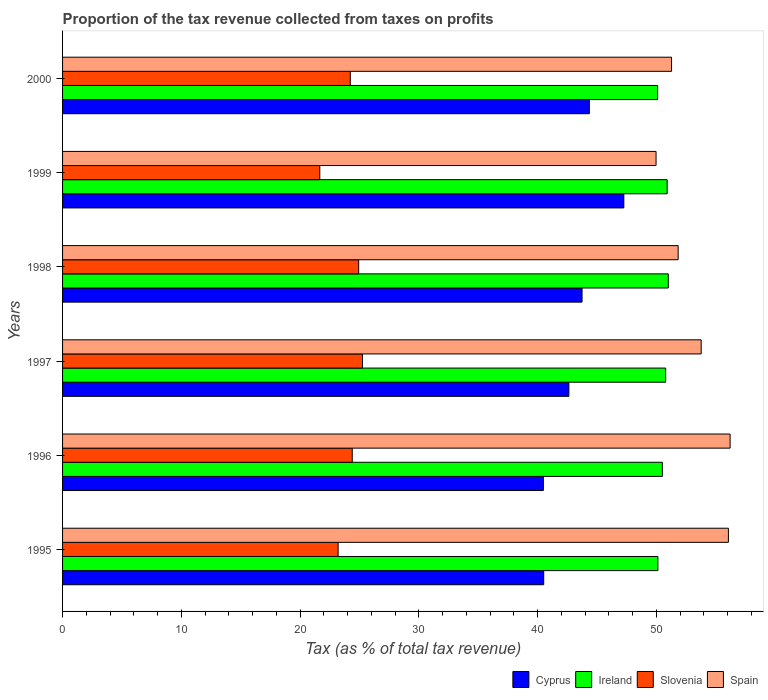How many different coloured bars are there?
Keep it short and to the point. 4. How many groups of bars are there?
Make the answer very short. 6. How many bars are there on the 6th tick from the bottom?
Provide a succinct answer. 4. What is the label of the 5th group of bars from the top?
Your response must be concise. 1996. In how many cases, is the number of bars for a given year not equal to the number of legend labels?
Offer a terse response. 0. What is the proportion of the tax revenue collected in Spain in 2000?
Your answer should be very brief. 51.28. Across all years, what is the maximum proportion of the tax revenue collected in Ireland?
Your response must be concise. 51. Across all years, what is the minimum proportion of the tax revenue collected in Slovenia?
Offer a terse response. 21.66. In which year was the proportion of the tax revenue collected in Ireland minimum?
Offer a very short reply. 2000. What is the total proportion of the tax revenue collected in Ireland in the graph?
Your answer should be compact. 303.43. What is the difference between the proportion of the tax revenue collected in Cyprus in 1995 and that in 2000?
Your answer should be compact. -3.84. What is the difference between the proportion of the tax revenue collected in Spain in 1995 and the proportion of the tax revenue collected in Ireland in 1998?
Keep it short and to the point. 5.06. What is the average proportion of the tax revenue collected in Slovenia per year?
Provide a succinct answer. 23.94. In the year 1999, what is the difference between the proportion of the tax revenue collected in Slovenia and proportion of the tax revenue collected in Ireland?
Your answer should be very brief. -29.25. What is the ratio of the proportion of the tax revenue collected in Spain in 1995 to that in 1999?
Offer a very short reply. 1.12. Is the difference between the proportion of the tax revenue collected in Slovenia in 1996 and 2000 greater than the difference between the proportion of the tax revenue collected in Ireland in 1996 and 2000?
Give a very brief answer. No. What is the difference between the highest and the second highest proportion of the tax revenue collected in Slovenia?
Offer a terse response. 0.32. What is the difference between the highest and the lowest proportion of the tax revenue collected in Cyprus?
Your answer should be very brief. 6.78. What does the 1st bar from the top in 2000 represents?
Give a very brief answer. Spain. What does the 2nd bar from the bottom in 1995 represents?
Offer a very short reply. Ireland. Is it the case that in every year, the sum of the proportion of the tax revenue collected in Slovenia and proportion of the tax revenue collected in Ireland is greater than the proportion of the tax revenue collected in Spain?
Your response must be concise. Yes. How many bars are there?
Make the answer very short. 24. How many years are there in the graph?
Give a very brief answer. 6. Are the values on the major ticks of X-axis written in scientific E-notation?
Ensure brevity in your answer.  No. Where does the legend appear in the graph?
Your response must be concise. Bottom right. How many legend labels are there?
Your answer should be very brief. 4. How are the legend labels stacked?
Ensure brevity in your answer.  Horizontal. What is the title of the graph?
Offer a terse response. Proportion of the tax revenue collected from taxes on profits. Does "Andorra" appear as one of the legend labels in the graph?
Your response must be concise. No. What is the label or title of the X-axis?
Offer a very short reply. Tax (as % of total tax revenue). What is the label or title of the Y-axis?
Ensure brevity in your answer.  Years. What is the Tax (as % of total tax revenue) of Cyprus in 1995?
Offer a terse response. 40.51. What is the Tax (as % of total tax revenue) of Ireland in 1995?
Keep it short and to the point. 50.13. What is the Tax (as % of total tax revenue) of Slovenia in 1995?
Keep it short and to the point. 23.2. What is the Tax (as % of total tax revenue) in Spain in 1995?
Make the answer very short. 56.07. What is the Tax (as % of total tax revenue) in Cyprus in 1996?
Make the answer very short. 40.48. What is the Tax (as % of total tax revenue) of Ireland in 1996?
Make the answer very short. 50.5. What is the Tax (as % of total tax revenue) in Slovenia in 1996?
Your response must be concise. 24.39. What is the Tax (as % of total tax revenue) in Spain in 1996?
Ensure brevity in your answer.  56.21. What is the Tax (as % of total tax revenue) in Cyprus in 1997?
Offer a terse response. 42.63. What is the Tax (as % of total tax revenue) in Ireland in 1997?
Keep it short and to the point. 50.78. What is the Tax (as % of total tax revenue) in Slovenia in 1997?
Provide a short and direct response. 25.25. What is the Tax (as % of total tax revenue) in Spain in 1997?
Ensure brevity in your answer.  53.77. What is the Tax (as % of total tax revenue) of Cyprus in 1998?
Give a very brief answer. 43.74. What is the Tax (as % of total tax revenue) in Ireland in 1998?
Ensure brevity in your answer.  51. What is the Tax (as % of total tax revenue) in Slovenia in 1998?
Provide a succinct answer. 24.93. What is the Tax (as % of total tax revenue) in Spain in 1998?
Give a very brief answer. 51.83. What is the Tax (as % of total tax revenue) in Cyprus in 1999?
Provide a short and direct response. 47.26. What is the Tax (as % of total tax revenue) of Ireland in 1999?
Offer a terse response. 50.91. What is the Tax (as % of total tax revenue) in Slovenia in 1999?
Make the answer very short. 21.66. What is the Tax (as % of total tax revenue) of Spain in 1999?
Your response must be concise. 49.97. What is the Tax (as % of total tax revenue) in Cyprus in 2000?
Your answer should be very brief. 44.35. What is the Tax (as % of total tax revenue) in Ireland in 2000?
Provide a succinct answer. 50.11. What is the Tax (as % of total tax revenue) in Slovenia in 2000?
Provide a short and direct response. 24.23. What is the Tax (as % of total tax revenue) in Spain in 2000?
Give a very brief answer. 51.28. Across all years, what is the maximum Tax (as % of total tax revenue) of Cyprus?
Your answer should be compact. 47.26. Across all years, what is the maximum Tax (as % of total tax revenue) in Ireland?
Provide a succinct answer. 51. Across all years, what is the maximum Tax (as % of total tax revenue) in Slovenia?
Keep it short and to the point. 25.25. Across all years, what is the maximum Tax (as % of total tax revenue) in Spain?
Make the answer very short. 56.21. Across all years, what is the minimum Tax (as % of total tax revenue) of Cyprus?
Your response must be concise. 40.48. Across all years, what is the minimum Tax (as % of total tax revenue) in Ireland?
Offer a terse response. 50.11. Across all years, what is the minimum Tax (as % of total tax revenue) of Slovenia?
Ensure brevity in your answer.  21.66. Across all years, what is the minimum Tax (as % of total tax revenue) of Spain?
Offer a terse response. 49.97. What is the total Tax (as % of total tax revenue) of Cyprus in the graph?
Ensure brevity in your answer.  258.98. What is the total Tax (as % of total tax revenue) in Ireland in the graph?
Your answer should be very brief. 303.43. What is the total Tax (as % of total tax revenue) of Slovenia in the graph?
Offer a very short reply. 143.67. What is the total Tax (as % of total tax revenue) of Spain in the graph?
Ensure brevity in your answer.  319.14. What is the difference between the Tax (as % of total tax revenue) of Cyprus in 1995 and that in 1996?
Keep it short and to the point. 0.03. What is the difference between the Tax (as % of total tax revenue) of Ireland in 1995 and that in 1996?
Keep it short and to the point. -0.38. What is the difference between the Tax (as % of total tax revenue) in Slovenia in 1995 and that in 1996?
Provide a succinct answer. -1.19. What is the difference between the Tax (as % of total tax revenue) in Spain in 1995 and that in 1996?
Offer a terse response. -0.14. What is the difference between the Tax (as % of total tax revenue) of Cyprus in 1995 and that in 1997?
Keep it short and to the point. -2.12. What is the difference between the Tax (as % of total tax revenue) of Ireland in 1995 and that in 1997?
Offer a terse response. -0.66. What is the difference between the Tax (as % of total tax revenue) of Slovenia in 1995 and that in 1997?
Your answer should be very brief. -2.05. What is the difference between the Tax (as % of total tax revenue) of Spain in 1995 and that in 1997?
Keep it short and to the point. 2.29. What is the difference between the Tax (as % of total tax revenue) of Cyprus in 1995 and that in 1998?
Keep it short and to the point. -3.23. What is the difference between the Tax (as % of total tax revenue) in Ireland in 1995 and that in 1998?
Give a very brief answer. -0.88. What is the difference between the Tax (as % of total tax revenue) of Slovenia in 1995 and that in 1998?
Ensure brevity in your answer.  -1.73. What is the difference between the Tax (as % of total tax revenue) of Spain in 1995 and that in 1998?
Ensure brevity in your answer.  4.23. What is the difference between the Tax (as % of total tax revenue) of Cyprus in 1995 and that in 1999?
Make the answer very short. -6.75. What is the difference between the Tax (as % of total tax revenue) of Ireland in 1995 and that in 1999?
Ensure brevity in your answer.  -0.78. What is the difference between the Tax (as % of total tax revenue) of Slovenia in 1995 and that in 1999?
Give a very brief answer. 1.54. What is the difference between the Tax (as % of total tax revenue) in Spain in 1995 and that in 1999?
Ensure brevity in your answer.  6.09. What is the difference between the Tax (as % of total tax revenue) of Cyprus in 1995 and that in 2000?
Give a very brief answer. -3.84. What is the difference between the Tax (as % of total tax revenue) of Ireland in 1995 and that in 2000?
Provide a succinct answer. 0.02. What is the difference between the Tax (as % of total tax revenue) in Slovenia in 1995 and that in 2000?
Provide a short and direct response. -1.02. What is the difference between the Tax (as % of total tax revenue) of Spain in 1995 and that in 2000?
Your answer should be very brief. 4.79. What is the difference between the Tax (as % of total tax revenue) of Cyprus in 1996 and that in 1997?
Provide a succinct answer. -2.15. What is the difference between the Tax (as % of total tax revenue) of Ireland in 1996 and that in 1997?
Offer a very short reply. -0.28. What is the difference between the Tax (as % of total tax revenue) in Slovenia in 1996 and that in 1997?
Your response must be concise. -0.86. What is the difference between the Tax (as % of total tax revenue) of Spain in 1996 and that in 1997?
Your answer should be compact. 2.44. What is the difference between the Tax (as % of total tax revenue) in Cyprus in 1996 and that in 1998?
Ensure brevity in your answer.  -3.26. What is the difference between the Tax (as % of total tax revenue) in Ireland in 1996 and that in 1998?
Your answer should be very brief. -0.5. What is the difference between the Tax (as % of total tax revenue) in Slovenia in 1996 and that in 1998?
Offer a very short reply. -0.54. What is the difference between the Tax (as % of total tax revenue) of Spain in 1996 and that in 1998?
Your answer should be very brief. 4.37. What is the difference between the Tax (as % of total tax revenue) in Cyprus in 1996 and that in 1999?
Offer a very short reply. -6.78. What is the difference between the Tax (as % of total tax revenue) in Ireland in 1996 and that in 1999?
Ensure brevity in your answer.  -0.4. What is the difference between the Tax (as % of total tax revenue) of Slovenia in 1996 and that in 1999?
Your answer should be very brief. 2.73. What is the difference between the Tax (as % of total tax revenue) in Spain in 1996 and that in 1999?
Offer a terse response. 6.24. What is the difference between the Tax (as % of total tax revenue) in Cyprus in 1996 and that in 2000?
Your response must be concise. -3.87. What is the difference between the Tax (as % of total tax revenue) in Ireland in 1996 and that in 2000?
Give a very brief answer. 0.4. What is the difference between the Tax (as % of total tax revenue) in Slovenia in 1996 and that in 2000?
Your answer should be very brief. 0.17. What is the difference between the Tax (as % of total tax revenue) of Spain in 1996 and that in 2000?
Give a very brief answer. 4.93. What is the difference between the Tax (as % of total tax revenue) of Cyprus in 1997 and that in 1998?
Your answer should be compact. -1.11. What is the difference between the Tax (as % of total tax revenue) in Ireland in 1997 and that in 1998?
Your answer should be very brief. -0.22. What is the difference between the Tax (as % of total tax revenue) of Slovenia in 1997 and that in 1998?
Keep it short and to the point. 0.32. What is the difference between the Tax (as % of total tax revenue) in Spain in 1997 and that in 1998?
Provide a succinct answer. 1.94. What is the difference between the Tax (as % of total tax revenue) in Cyprus in 1997 and that in 1999?
Your answer should be very brief. -4.63. What is the difference between the Tax (as % of total tax revenue) of Ireland in 1997 and that in 1999?
Offer a very short reply. -0.12. What is the difference between the Tax (as % of total tax revenue) of Slovenia in 1997 and that in 1999?
Offer a very short reply. 3.59. What is the difference between the Tax (as % of total tax revenue) of Spain in 1997 and that in 1999?
Offer a very short reply. 3.8. What is the difference between the Tax (as % of total tax revenue) in Cyprus in 1997 and that in 2000?
Your answer should be compact. -1.72. What is the difference between the Tax (as % of total tax revenue) of Ireland in 1997 and that in 2000?
Give a very brief answer. 0.68. What is the difference between the Tax (as % of total tax revenue) in Slovenia in 1997 and that in 2000?
Make the answer very short. 1.03. What is the difference between the Tax (as % of total tax revenue) in Spain in 1997 and that in 2000?
Offer a terse response. 2.5. What is the difference between the Tax (as % of total tax revenue) in Cyprus in 1998 and that in 1999?
Provide a succinct answer. -3.52. What is the difference between the Tax (as % of total tax revenue) of Ireland in 1998 and that in 1999?
Offer a very short reply. 0.1. What is the difference between the Tax (as % of total tax revenue) of Slovenia in 1998 and that in 1999?
Provide a succinct answer. 3.27. What is the difference between the Tax (as % of total tax revenue) of Spain in 1998 and that in 1999?
Your answer should be compact. 1.86. What is the difference between the Tax (as % of total tax revenue) in Cyprus in 1998 and that in 2000?
Ensure brevity in your answer.  -0.61. What is the difference between the Tax (as % of total tax revenue) in Ireland in 1998 and that in 2000?
Offer a very short reply. 0.9. What is the difference between the Tax (as % of total tax revenue) of Slovenia in 1998 and that in 2000?
Your answer should be very brief. 0.71. What is the difference between the Tax (as % of total tax revenue) in Spain in 1998 and that in 2000?
Make the answer very short. 0.56. What is the difference between the Tax (as % of total tax revenue) of Cyprus in 1999 and that in 2000?
Your answer should be compact. 2.91. What is the difference between the Tax (as % of total tax revenue) of Ireland in 1999 and that in 2000?
Ensure brevity in your answer.  0.8. What is the difference between the Tax (as % of total tax revenue) in Slovenia in 1999 and that in 2000?
Offer a terse response. -2.57. What is the difference between the Tax (as % of total tax revenue) of Spain in 1999 and that in 2000?
Make the answer very short. -1.3. What is the difference between the Tax (as % of total tax revenue) in Cyprus in 1995 and the Tax (as % of total tax revenue) in Ireland in 1996?
Your answer should be very brief. -9.99. What is the difference between the Tax (as % of total tax revenue) of Cyprus in 1995 and the Tax (as % of total tax revenue) of Slovenia in 1996?
Offer a very short reply. 16.12. What is the difference between the Tax (as % of total tax revenue) in Cyprus in 1995 and the Tax (as % of total tax revenue) in Spain in 1996?
Offer a very short reply. -15.7. What is the difference between the Tax (as % of total tax revenue) in Ireland in 1995 and the Tax (as % of total tax revenue) in Slovenia in 1996?
Your response must be concise. 25.73. What is the difference between the Tax (as % of total tax revenue) in Ireland in 1995 and the Tax (as % of total tax revenue) in Spain in 1996?
Offer a terse response. -6.08. What is the difference between the Tax (as % of total tax revenue) of Slovenia in 1995 and the Tax (as % of total tax revenue) of Spain in 1996?
Your answer should be very brief. -33.01. What is the difference between the Tax (as % of total tax revenue) of Cyprus in 1995 and the Tax (as % of total tax revenue) of Ireland in 1997?
Provide a short and direct response. -10.27. What is the difference between the Tax (as % of total tax revenue) of Cyprus in 1995 and the Tax (as % of total tax revenue) of Slovenia in 1997?
Your answer should be compact. 15.26. What is the difference between the Tax (as % of total tax revenue) in Cyprus in 1995 and the Tax (as % of total tax revenue) in Spain in 1997?
Give a very brief answer. -13.26. What is the difference between the Tax (as % of total tax revenue) in Ireland in 1995 and the Tax (as % of total tax revenue) in Slovenia in 1997?
Your answer should be very brief. 24.87. What is the difference between the Tax (as % of total tax revenue) of Ireland in 1995 and the Tax (as % of total tax revenue) of Spain in 1997?
Your answer should be compact. -3.65. What is the difference between the Tax (as % of total tax revenue) of Slovenia in 1995 and the Tax (as % of total tax revenue) of Spain in 1997?
Offer a very short reply. -30.57. What is the difference between the Tax (as % of total tax revenue) in Cyprus in 1995 and the Tax (as % of total tax revenue) in Ireland in 1998?
Your response must be concise. -10.49. What is the difference between the Tax (as % of total tax revenue) of Cyprus in 1995 and the Tax (as % of total tax revenue) of Slovenia in 1998?
Make the answer very short. 15.58. What is the difference between the Tax (as % of total tax revenue) in Cyprus in 1995 and the Tax (as % of total tax revenue) in Spain in 1998?
Your answer should be compact. -11.32. What is the difference between the Tax (as % of total tax revenue) in Ireland in 1995 and the Tax (as % of total tax revenue) in Slovenia in 1998?
Your answer should be compact. 25.19. What is the difference between the Tax (as % of total tax revenue) in Ireland in 1995 and the Tax (as % of total tax revenue) in Spain in 1998?
Offer a very short reply. -1.71. What is the difference between the Tax (as % of total tax revenue) in Slovenia in 1995 and the Tax (as % of total tax revenue) in Spain in 1998?
Offer a very short reply. -28.63. What is the difference between the Tax (as % of total tax revenue) in Cyprus in 1995 and the Tax (as % of total tax revenue) in Ireland in 1999?
Your answer should be compact. -10.39. What is the difference between the Tax (as % of total tax revenue) in Cyprus in 1995 and the Tax (as % of total tax revenue) in Slovenia in 1999?
Provide a succinct answer. 18.85. What is the difference between the Tax (as % of total tax revenue) in Cyprus in 1995 and the Tax (as % of total tax revenue) in Spain in 1999?
Give a very brief answer. -9.46. What is the difference between the Tax (as % of total tax revenue) in Ireland in 1995 and the Tax (as % of total tax revenue) in Slovenia in 1999?
Give a very brief answer. 28.47. What is the difference between the Tax (as % of total tax revenue) in Ireland in 1995 and the Tax (as % of total tax revenue) in Spain in 1999?
Provide a short and direct response. 0.15. What is the difference between the Tax (as % of total tax revenue) in Slovenia in 1995 and the Tax (as % of total tax revenue) in Spain in 1999?
Keep it short and to the point. -26.77. What is the difference between the Tax (as % of total tax revenue) in Cyprus in 1995 and the Tax (as % of total tax revenue) in Ireland in 2000?
Provide a succinct answer. -9.59. What is the difference between the Tax (as % of total tax revenue) of Cyprus in 1995 and the Tax (as % of total tax revenue) of Slovenia in 2000?
Give a very brief answer. 16.29. What is the difference between the Tax (as % of total tax revenue) in Cyprus in 1995 and the Tax (as % of total tax revenue) in Spain in 2000?
Your answer should be very brief. -10.77. What is the difference between the Tax (as % of total tax revenue) of Ireland in 1995 and the Tax (as % of total tax revenue) of Slovenia in 2000?
Give a very brief answer. 25.9. What is the difference between the Tax (as % of total tax revenue) of Ireland in 1995 and the Tax (as % of total tax revenue) of Spain in 2000?
Provide a short and direct response. -1.15. What is the difference between the Tax (as % of total tax revenue) of Slovenia in 1995 and the Tax (as % of total tax revenue) of Spain in 2000?
Your response must be concise. -28.08. What is the difference between the Tax (as % of total tax revenue) of Cyprus in 1996 and the Tax (as % of total tax revenue) of Ireland in 1997?
Offer a very short reply. -10.3. What is the difference between the Tax (as % of total tax revenue) of Cyprus in 1996 and the Tax (as % of total tax revenue) of Slovenia in 1997?
Provide a succinct answer. 15.23. What is the difference between the Tax (as % of total tax revenue) of Cyprus in 1996 and the Tax (as % of total tax revenue) of Spain in 1997?
Ensure brevity in your answer.  -13.29. What is the difference between the Tax (as % of total tax revenue) in Ireland in 1996 and the Tax (as % of total tax revenue) in Slovenia in 1997?
Your answer should be compact. 25.25. What is the difference between the Tax (as % of total tax revenue) of Ireland in 1996 and the Tax (as % of total tax revenue) of Spain in 1997?
Your answer should be very brief. -3.27. What is the difference between the Tax (as % of total tax revenue) in Slovenia in 1996 and the Tax (as % of total tax revenue) in Spain in 1997?
Keep it short and to the point. -29.38. What is the difference between the Tax (as % of total tax revenue) of Cyprus in 1996 and the Tax (as % of total tax revenue) of Ireland in 1998?
Provide a short and direct response. -10.52. What is the difference between the Tax (as % of total tax revenue) of Cyprus in 1996 and the Tax (as % of total tax revenue) of Slovenia in 1998?
Provide a short and direct response. 15.55. What is the difference between the Tax (as % of total tax revenue) of Cyprus in 1996 and the Tax (as % of total tax revenue) of Spain in 1998?
Provide a short and direct response. -11.35. What is the difference between the Tax (as % of total tax revenue) of Ireland in 1996 and the Tax (as % of total tax revenue) of Slovenia in 1998?
Ensure brevity in your answer.  25.57. What is the difference between the Tax (as % of total tax revenue) in Ireland in 1996 and the Tax (as % of total tax revenue) in Spain in 1998?
Offer a very short reply. -1.33. What is the difference between the Tax (as % of total tax revenue) in Slovenia in 1996 and the Tax (as % of total tax revenue) in Spain in 1998?
Keep it short and to the point. -27.44. What is the difference between the Tax (as % of total tax revenue) of Cyprus in 1996 and the Tax (as % of total tax revenue) of Ireland in 1999?
Your answer should be compact. -10.42. What is the difference between the Tax (as % of total tax revenue) of Cyprus in 1996 and the Tax (as % of total tax revenue) of Slovenia in 1999?
Your response must be concise. 18.82. What is the difference between the Tax (as % of total tax revenue) in Cyprus in 1996 and the Tax (as % of total tax revenue) in Spain in 1999?
Ensure brevity in your answer.  -9.49. What is the difference between the Tax (as % of total tax revenue) of Ireland in 1996 and the Tax (as % of total tax revenue) of Slovenia in 1999?
Provide a succinct answer. 28.84. What is the difference between the Tax (as % of total tax revenue) in Ireland in 1996 and the Tax (as % of total tax revenue) in Spain in 1999?
Provide a short and direct response. 0.53. What is the difference between the Tax (as % of total tax revenue) in Slovenia in 1996 and the Tax (as % of total tax revenue) in Spain in 1999?
Offer a very short reply. -25.58. What is the difference between the Tax (as % of total tax revenue) of Cyprus in 1996 and the Tax (as % of total tax revenue) of Ireland in 2000?
Offer a very short reply. -9.62. What is the difference between the Tax (as % of total tax revenue) in Cyprus in 1996 and the Tax (as % of total tax revenue) in Slovenia in 2000?
Offer a very short reply. 16.26. What is the difference between the Tax (as % of total tax revenue) in Cyprus in 1996 and the Tax (as % of total tax revenue) in Spain in 2000?
Your response must be concise. -10.79. What is the difference between the Tax (as % of total tax revenue) in Ireland in 1996 and the Tax (as % of total tax revenue) in Slovenia in 2000?
Your answer should be very brief. 26.28. What is the difference between the Tax (as % of total tax revenue) in Ireland in 1996 and the Tax (as % of total tax revenue) in Spain in 2000?
Give a very brief answer. -0.77. What is the difference between the Tax (as % of total tax revenue) of Slovenia in 1996 and the Tax (as % of total tax revenue) of Spain in 2000?
Offer a very short reply. -26.89. What is the difference between the Tax (as % of total tax revenue) of Cyprus in 1997 and the Tax (as % of total tax revenue) of Ireland in 1998?
Ensure brevity in your answer.  -8.37. What is the difference between the Tax (as % of total tax revenue) in Cyprus in 1997 and the Tax (as % of total tax revenue) in Slovenia in 1998?
Ensure brevity in your answer.  17.7. What is the difference between the Tax (as % of total tax revenue) of Cyprus in 1997 and the Tax (as % of total tax revenue) of Spain in 1998?
Your answer should be very brief. -9.2. What is the difference between the Tax (as % of total tax revenue) in Ireland in 1997 and the Tax (as % of total tax revenue) in Slovenia in 1998?
Provide a succinct answer. 25.85. What is the difference between the Tax (as % of total tax revenue) in Ireland in 1997 and the Tax (as % of total tax revenue) in Spain in 1998?
Provide a short and direct response. -1.05. What is the difference between the Tax (as % of total tax revenue) in Slovenia in 1997 and the Tax (as % of total tax revenue) in Spain in 1998?
Keep it short and to the point. -26.58. What is the difference between the Tax (as % of total tax revenue) in Cyprus in 1997 and the Tax (as % of total tax revenue) in Ireland in 1999?
Provide a short and direct response. -8.27. What is the difference between the Tax (as % of total tax revenue) of Cyprus in 1997 and the Tax (as % of total tax revenue) of Slovenia in 1999?
Make the answer very short. 20.97. What is the difference between the Tax (as % of total tax revenue) of Cyprus in 1997 and the Tax (as % of total tax revenue) of Spain in 1999?
Keep it short and to the point. -7.34. What is the difference between the Tax (as % of total tax revenue) in Ireland in 1997 and the Tax (as % of total tax revenue) in Slovenia in 1999?
Offer a very short reply. 29.12. What is the difference between the Tax (as % of total tax revenue) in Ireland in 1997 and the Tax (as % of total tax revenue) in Spain in 1999?
Give a very brief answer. 0.81. What is the difference between the Tax (as % of total tax revenue) in Slovenia in 1997 and the Tax (as % of total tax revenue) in Spain in 1999?
Your answer should be compact. -24.72. What is the difference between the Tax (as % of total tax revenue) of Cyprus in 1997 and the Tax (as % of total tax revenue) of Ireland in 2000?
Keep it short and to the point. -7.47. What is the difference between the Tax (as % of total tax revenue) of Cyprus in 1997 and the Tax (as % of total tax revenue) of Slovenia in 2000?
Your answer should be compact. 18.41. What is the difference between the Tax (as % of total tax revenue) of Cyprus in 1997 and the Tax (as % of total tax revenue) of Spain in 2000?
Your answer should be very brief. -8.64. What is the difference between the Tax (as % of total tax revenue) in Ireland in 1997 and the Tax (as % of total tax revenue) in Slovenia in 2000?
Your response must be concise. 26.56. What is the difference between the Tax (as % of total tax revenue) in Ireland in 1997 and the Tax (as % of total tax revenue) in Spain in 2000?
Provide a short and direct response. -0.49. What is the difference between the Tax (as % of total tax revenue) in Slovenia in 1997 and the Tax (as % of total tax revenue) in Spain in 2000?
Make the answer very short. -26.02. What is the difference between the Tax (as % of total tax revenue) in Cyprus in 1998 and the Tax (as % of total tax revenue) in Ireland in 1999?
Give a very brief answer. -7.17. What is the difference between the Tax (as % of total tax revenue) in Cyprus in 1998 and the Tax (as % of total tax revenue) in Slovenia in 1999?
Keep it short and to the point. 22.08. What is the difference between the Tax (as % of total tax revenue) in Cyprus in 1998 and the Tax (as % of total tax revenue) in Spain in 1999?
Your answer should be compact. -6.23. What is the difference between the Tax (as % of total tax revenue) in Ireland in 1998 and the Tax (as % of total tax revenue) in Slovenia in 1999?
Provide a succinct answer. 29.34. What is the difference between the Tax (as % of total tax revenue) of Ireland in 1998 and the Tax (as % of total tax revenue) of Spain in 1999?
Your response must be concise. 1.03. What is the difference between the Tax (as % of total tax revenue) in Slovenia in 1998 and the Tax (as % of total tax revenue) in Spain in 1999?
Provide a succinct answer. -25.04. What is the difference between the Tax (as % of total tax revenue) in Cyprus in 1998 and the Tax (as % of total tax revenue) in Ireland in 2000?
Provide a succinct answer. -6.36. What is the difference between the Tax (as % of total tax revenue) in Cyprus in 1998 and the Tax (as % of total tax revenue) in Slovenia in 2000?
Make the answer very short. 19.51. What is the difference between the Tax (as % of total tax revenue) of Cyprus in 1998 and the Tax (as % of total tax revenue) of Spain in 2000?
Provide a short and direct response. -7.54. What is the difference between the Tax (as % of total tax revenue) in Ireland in 1998 and the Tax (as % of total tax revenue) in Slovenia in 2000?
Offer a very short reply. 26.78. What is the difference between the Tax (as % of total tax revenue) in Ireland in 1998 and the Tax (as % of total tax revenue) in Spain in 2000?
Provide a succinct answer. -0.27. What is the difference between the Tax (as % of total tax revenue) in Slovenia in 1998 and the Tax (as % of total tax revenue) in Spain in 2000?
Keep it short and to the point. -26.34. What is the difference between the Tax (as % of total tax revenue) in Cyprus in 1999 and the Tax (as % of total tax revenue) in Ireland in 2000?
Ensure brevity in your answer.  -2.85. What is the difference between the Tax (as % of total tax revenue) of Cyprus in 1999 and the Tax (as % of total tax revenue) of Slovenia in 2000?
Provide a short and direct response. 23.03. What is the difference between the Tax (as % of total tax revenue) of Cyprus in 1999 and the Tax (as % of total tax revenue) of Spain in 2000?
Make the answer very short. -4.02. What is the difference between the Tax (as % of total tax revenue) in Ireland in 1999 and the Tax (as % of total tax revenue) in Slovenia in 2000?
Your answer should be very brief. 26.68. What is the difference between the Tax (as % of total tax revenue) of Ireland in 1999 and the Tax (as % of total tax revenue) of Spain in 2000?
Make the answer very short. -0.37. What is the difference between the Tax (as % of total tax revenue) of Slovenia in 1999 and the Tax (as % of total tax revenue) of Spain in 2000?
Your answer should be very brief. -29.62. What is the average Tax (as % of total tax revenue) of Cyprus per year?
Provide a succinct answer. 43.16. What is the average Tax (as % of total tax revenue) of Ireland per year?
Make the answer very short. 50.57. What is the average Tax (as % of total tax revenue) of Slovenia per year?
Make the answer very short. 23.94. What is the average Tax (as % of total tax revenue) of Spain per year?
Offer a terse response. 53.19. In the year 1995, what is the difference between the Tax (as % of total tax revenue) of Cyprus and Tax (as % of total tax revenue) of Ireland?
Offer a terse response. -9.61. In the year 1995, what is the difference between the Tax (as % of total tax revenue) in Cyprus and Tax (as % of total tax revenue) in Slovenia?
Ensure brevity in your answer.  17.31. In the year 1995, what is the difference between the Tax (as % of total tax revenue) of Cyprus and Tax (as % of total tax revenue) of Spain?
Keep it short and to the point. -15.55. In the year 1995, what is the difference between the Tax (as % of total tax revenue) of Ireland and Tax (as % of total tax revenue) of Slovenia?
Ensure brevity in your answer.  26.93. In the year 1995, what is the difference between the Tax (as % of total tax revenue) in Ireland and Tax (as % of total tax revenue) in Spain?
Ensure brevity in your answer.  -5.94. In the year 1995, what is the difference between the Tax (as % of total tax revenue) of Slovenia and Tax (as % of total tax revenue) of Spain?
Ensure brevity in your answer.  -32.86. In the year 1996, what is the difference between the Tax (as % of total tax revenue) in Cyprus and Tax (as % of total tax revenue) in Ireland?
Keep it short and to the point. -10.02. In the year 1996, what is the difference between the Tax (as % of total tax revenue) in Cyprus and Tax (as % of total tax revenue) in Slovenia?
Offer a very short reply. 16.09. In the year 1996, what is the difference between the Tax (as % of total tax revenue) of Cyprus and Tax (as % of total tax revenue) of Spain?
Your response must be concise. -15.73. In the year 1996, what is the difference between the Tax (as % of total tax revenue) of Ireland and Tax (as % of total tax revenue) of Slovenia?
Offer a terse response. 26.11. In the year 1996, what is the difference between the Tax (as % of total tax revenue) in Ireland and Tax (as % of total tax revenue) in Spain?
Offer a very short reply. -5.71. In the year 1996, what is the difference between the Tax (as % of total tax revenue) of Slovenia and Tax (as % of total tax revenue) of Spain?
Offer a terse response. -31.82. In the year 1997, what is the difference between the Tax (as % of total tax revenue) of Cyprus and Tax (as % of total tax revenue) of Ireland?
Offer a very short reply. -8.15. In the year 1997, what is the difference between the Tax (as % of total tax revenue) of Cyprus and Tax (as % of total tax revenue) of Slovenia?
Make the answer very short. 17.38. In the year 1997, what is the difference between the Tax (as % of total tax revenue) in Cyprus and Tax (as % of total tax revenue) in Spain?
Make the answer very short. -11.14. In the year 1997, what is the difference between the Tax (as % of total tax revenue) in Ireland and Tax (as % of total tax revenue) in Slovenia?
Ensure brevity in your answer.  25.53. In the year 1997, what is the difference between the Tax (as % of total tax revenue) of Ireland and Tax (as % of total tax revenue) of Spain?
Make the answer very short. -2.99. In the year 1997, what is the difference between the Tax (as % of total tax revenue) in Slovenia and Tax (as % of total tax revenue) in Spain?
Provide a succinct answer. -28.52. In the year 1998, what is the difference between the Tax (as % of total tax revenue) in Cyprus and Tax (as % of total tax revenue) in Ireland?
Keep it short and to the point. -7.26. In the year 1998, what is the difference between the Tax (as % of total tax revenue) in Cyprus and Tax (as % of total tax revenue) in Slovenia?
Your response must be concise. 18.81. In the year 1998, what is the difference between the Tax (as % of total tax revenue) of Cyprus and Tax (as % of total tax revenue) of Spain?
Offer a terse response. -8.09. In the year 1998, what is the difference between the Tax (as % of total tax revenue) of Ireland and Tax (as % of total tax revenue) of Slovenia?
Keep it short and to the point. 26.07. In the year 1998, what is the difference between the Tax (as % of total tax revenue) of Ireland and Tax (as % of total tax revenue) of Spain?
Your response must be concise. -0.83. In the year 1998, what is the difference between the Tax (as % of total tax revenue) in Slovenia and Tax (as % of total tax revenue) in Spain?
Provide a short and direct response. -26.9. In the year 1999, what is the difference between the Tax (as % of total tax revenue) of Cyprus and Tax (as % of total tax revenue) of Ireland?
Offer a terse response. -3.65. In the year 1999, what is the difference between the Tax (as % of total tax revenue) in Cyprus and Tax (as % of total tax revenue) in Slovenia?
Make the answer very short. 25.6. In the year 1999, what is the difference between the Tax (as % of total tax revenue) in Cyprus and Tax (as % of total tax revenue) in Spain?
Give a very brief answer. -2.71. In the year 1999, what is the difference between the Tax (as % of total tax revenue) in Ireland and Tax (as % of total tax revenue) in Slovenia?
Your response must be concise. 29.25. In the year 1999, what is the difference between the Tax (as % of total tax revenue) in Ireland and Tax (as % of total tax revenue) in Spain?
Keep it short and to the point. 0.93. In the year 1999, what is the difference between the Tax (as % of total tax revenue) in Slovenia and Tax (as % of total tax revenue) in Spain?
Provide a short and direct response. -28.31. In the year 2000, what is the difference between the Tax (as % of total tax revenue) in Cyprus and Tax (as % of total tax revenue) in Ireland?
Make the answer very short. -5.75. In the year 2000, what is the difference between the Tax (as % of total tax revenue) in Cyprus and Tax (as % of total tax revenue) in Slovenia?
Provide a succinct answer. 20.13. In the year 2000, what is the difference between the Tax (as % of total tax revenue) in Cyprus and Tax (as % of total tax revenue) in Spain?
Give a very brief answer. -6.92. In the year 2000, what is the difference between the Tax (as % of total tax revenue) of Ireland and Tax (as % of total tax revenue) of Slovenia?
Make the answer very short. 25.88. In the year 2000, what is the difference between the Tax (as % of total tax revenue) in Ireland and Tax (as % of total tax revenue) in Spain?
Keep it short and to the point. -1.17. In the year 2000, what is the difference between the Tax (as % of total tax revenue) of Slovenia and Tax (as % of total tax revenue) of Spain?
Offer a terse response. -27.05. What is the ratio of the Tax (as % of total tax revenue) of Slovenia in 1995 to that in 1996?
Offer a terse response. 0.95. What is the ratio of the Tax (as % of total tax revenue) in Cyprus in 1995 to that in 1997?
Provide a succinct answer. 0.95. What is the ratio of the Tax (as % of total tax revenue) of Ireland in 1995 to that in 1997?
Provide a succinct answer. 0.99. What is the ratio of the Tax (as % of total tax revenue) of Slovenia in 1995 to that in 1997?
Keep it short and to the point. 0.92. What is the ratio of the Tax (as % of total tax revenue) in Spain in 1995 to that in 1997?
Offer a very short reply. 1.04. What is the ratio of the Tax (as % of total tax revenue) in Cyprus in 1995 to that in 1998?
Ensure brevity in your answer.  0.93. What is the ratio of the Tax (as % of total tax revenue) of Ireland in 1995 to that in 1998?
Offer a terse response. 0.98. What is the ratio of the Tax (as % of total tax revenue) in Slovenia in 1995 to that in 1998?
Provide a short and direct response. 0.93. What is the ratio of the Tax (as % of total tax revenue) of Spain in 1995 to that in 1998?
Provide a succinct answer. 1.08. What is the ratio of the Tax (as % of total tax revenue) of Cyprus in 1995 to that in 1999?
Your answer should be very brief. 0.86. What is the ratio of the Tax (as % of total tax revenue) in Ireland in 1995 to that in 1999?
Offer a terse response. 0.98. What is the ratio of the Tax (as % of total tax revenue) of Slovenia in 1995 to that in 1999?
Provide a succinct answer. 1.07. What is the ratio of the Tax (as % of total tax revenue) in Spain in 1995 to that in 1999?
Give a very brief answer. 1.12. What is the ratio of the Tax (as % of total tax revenue) in Cyprus in 1995 to that in 2000?
Give a very brief answer. 0.91. What is the ratio of the Tax (as % of total tax revenue) in Ireland in 1995 to that in 2000?
Your response must be concise. 1. What is the ratio of the Tax (as % of total tax revenue) in Slovenia in 1995 to that in 2000?
Ensure brevity in your answer.  0.96. What is the ratio of the Tax (as % of total tax revenue) of Spain in 1995 to that in 2000?
Your answer should be compact. 1.09. What is the ratio of the Tax (as % of total tax revenue) of Cyprus in 1996 to that in 1997?
Your answer should be compact. 0.95. What is the ratio of the Tax (as % of total tax revenue) in Slovenia in 1996 to that in 1997?
Ensure brevity in your answer.  0.97. What is the ratio of the Tax (as % of total tax revenue) of Spain in 1996 to that in 1997?
Offer a terse response. 1.05. What is the ratio of the Tax (as % of total tax revenue) in Cyprus in 1996 to that in 1998?
Keep it short and to the point. 0.93. What is the ratio of the Tax (as % of total tax revenue) in Ireland in 1996 to that in 1998?
Offer a terse response. 0.99. What is the ratio of the Tax (as % of total tax revenue) in Slovenia in 1996 to that in 1998?
Provide a short and direct response. 0.98. What is the ratio of the Tax (as % of total tax revenue) in Spain in 1996 to that in 1998?
Ensure brevity in your answer.  1.08. What is the ratio of the Tax (as % of total tax revenue) in Cyprus in 1996 to that in 1999?
Your answer should be compact. 0.86. What is the ratio of the Tax (as % of total tax revenue) of Slovenia in 1996 to that in 1999?
Provide a succinct answer. 1.13. What is the ratio of the Tax (as % of total tax revenue) of Spain in 1996 to that in 1999?
Give a very brief answer. 1.12. What is the ratio of the Tax (as % of total tax revenue) in Cyprus in 1996 to that in 2000?
Provide a succinct answer. 0.91. What is the ratio of the Tax (as % of total tax revenue) in Ireland in 1996 to that in 2000?
Ensure brevity in your answer.  1.01. What is the ratio of the Tax (as % of total tax revenue) of Slovenia in 1996 to that in 2000?
Your answer should be compact. 1.01. What is the ratio of the Tax (as % of total tax revenue) of Spain in 1996 to that in 2000?
Your response must be concise. 1.1. What is the ratio of the Tax (as % of total tax revenue) in Cyprus in 1997 to that in 1998?
Offer a very short reply. 0.97. What is the ratio of the Tax (as % of total tax revenue) of Ireland in 1997 to that in 1998?
Offer a terse response. 1. What is the ratio of the Tax (as % of total tax revenue) of Slovenia in 1997 to that in 1998?
Ensure brevity in your answer.  1.01. What is the ratio of the Tax (as % of total tax revenue) of Spain in 1997 to that in 1998?
Your answer should be very brief. 1.04. What is the ratio of the Tax (as % of total tax revenue) of Cyprus in 1997 to that in 1999?
Offer a very short reply. 0.9. What is the ratio of the Tax (as % of total tax revenue) of Ireland in 1997 to that in 1999?
Provide a succinct answer. 1. What is the ratio of the Tax (as % of total tax revenue) of Slovenia in 1997 to that in 1999?
Offer a very short reply. 1.17. What is the ratio of the Tax (as % of total tax revenue) of Spain in 1997 to that in 1999?
Offer a very short reply. 1.08. What is the ratio of the Tax (as % of total tax revenue) of Cyprus in 1997 to that in 2000?
Make the answer very short. 0.96. What is the ratio of the Tax (as % of total tax revenue) of Ireland in 1997 to that in 2000?
Provide a succinct answer. 1.01. What is the ratio of the Tax (as % of total tax revenue) in Slovenia in 1997 to that in 2000?
Offer a terse response. 1.04. What is the ratio of the Tax (as % of total tax revenue) in Spain in 1997 to that in 2000?
Make the answer very short. 1.05. What is the ratio of the Tax (as % of total tax revenue) of Cyprus in 1998 to that in 1999?
Provide a succinct answer. 0.93. What is the ratio of the Tax (as % of total tax revenue) of Ireland in 1998 to that in 1999?
Ensure brevity in your answer.  1. What is the ratio of the Tax (as % of total tax revenue) of Slovenia in 1998 to that in 1999?
Make the answer very short. 1.15. What is the ratio of the Tax (as % of total tax revenue) in Spain in 1998 to that in 1999?
Your response must be concise. 1.04. What is the ratio of the Tax (as % of total tax revenue) in Cyprus in 1998 to that in 2000?
Offer a very short reply. 0.99. What is the ratio of the Tax (as % of total tax revenue) in Ireland in 1998 to that in 2000?
Your answer should be very brief. 1.02. What is the ratio of the Tax (as % of total tax revenue) in Slovenia in 1998 to that in 2000?
Provide a succinct answer. 1.03. What is the ratio of the Tax (as % of total tax revenue) of Spain in 1998 to that in 2000?
Offer a terse response. 1.01. What is the ratio of the Tax (as % of total tax revenue) in Cyprus in 1999 to that in 2000?
Ensure brevity in your answer.  1.07. What is the ratio of the Tax (as % of total tax revenue) of Ireland in 1999 to that in 2000?
Provide a short and direct response. 1.02. What is the ratio of the Tax (as % of total tax revenue) in Slovenia in 1999 to that in 2000?
Ensure brevity in your answer.  0.89. What is the ratio of the Tax (as % of total tax revenue) in Spain in 1999 to that in 2000?
Provide a succinct answer. 0.97. What is the difference between the highest and the second highest Tax (as % of total tax revenue) in Cyprus?
Offer a terse response. 2.91. What is the difference between the highest and the second highest Tax (as % of total tax revenue) of Ireland?
Give a very brief answer. 0.1. What is the difference between the highest and the second highest Tax (as % of total tax revenue) of Slovenia?
Provide a short and direct response. 0.32. What is the difference between the highest and the second highest Tax (as % of total tax revenue) of Spain?
Offer a very short reply. 0.14. What is the difference between the highest and the lowest Tax (as % of total tax revenue) of Cyprus?
Your answer should be compact. 6.78. What is the difference between the highest and the lowest Tax (as % of total tax revenue) in Ireland?
Your answer should be compact. 0.9. What is the difference between the highest and the lowest Tax (as % of total tax revenue) in Slovenia?
Give a very brief answer. 3.59. What is the difference between the highest and the lowest Tax (as % of total tax revenue) of Spain?
Give a very brief answer. 6.24. 